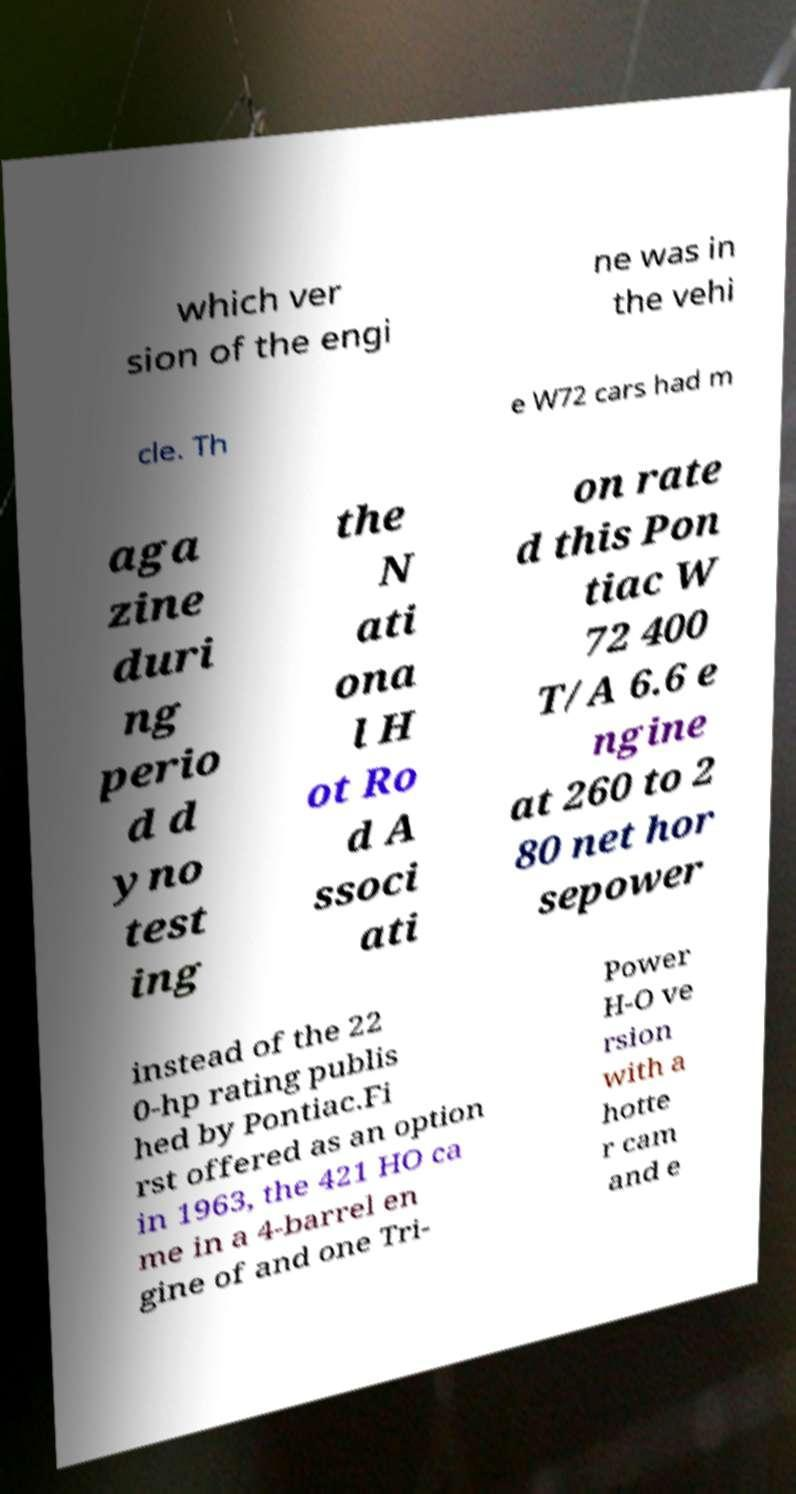For documentation purposes, I need the text within this image transcribed. Could you provide that? which ver sion of the engi ne was in the vehi cle. Th e W72 cars had m aga zine duri ng perio d d yno test ing the N ati ona l H ot Ro d A ssoci ati on rate d this Pon tiac W 72 400 T/A 6.6 e ngine at 260 to 2 80 net hor sepower instead of the 22 0-hp rating publis hed by Pontiac.Fi rst offered as an option in 1963, the 421 HO ca me in a 4-barrel en gine of and one Tri- Power H-O ve rsion with a hotte r cam and e 